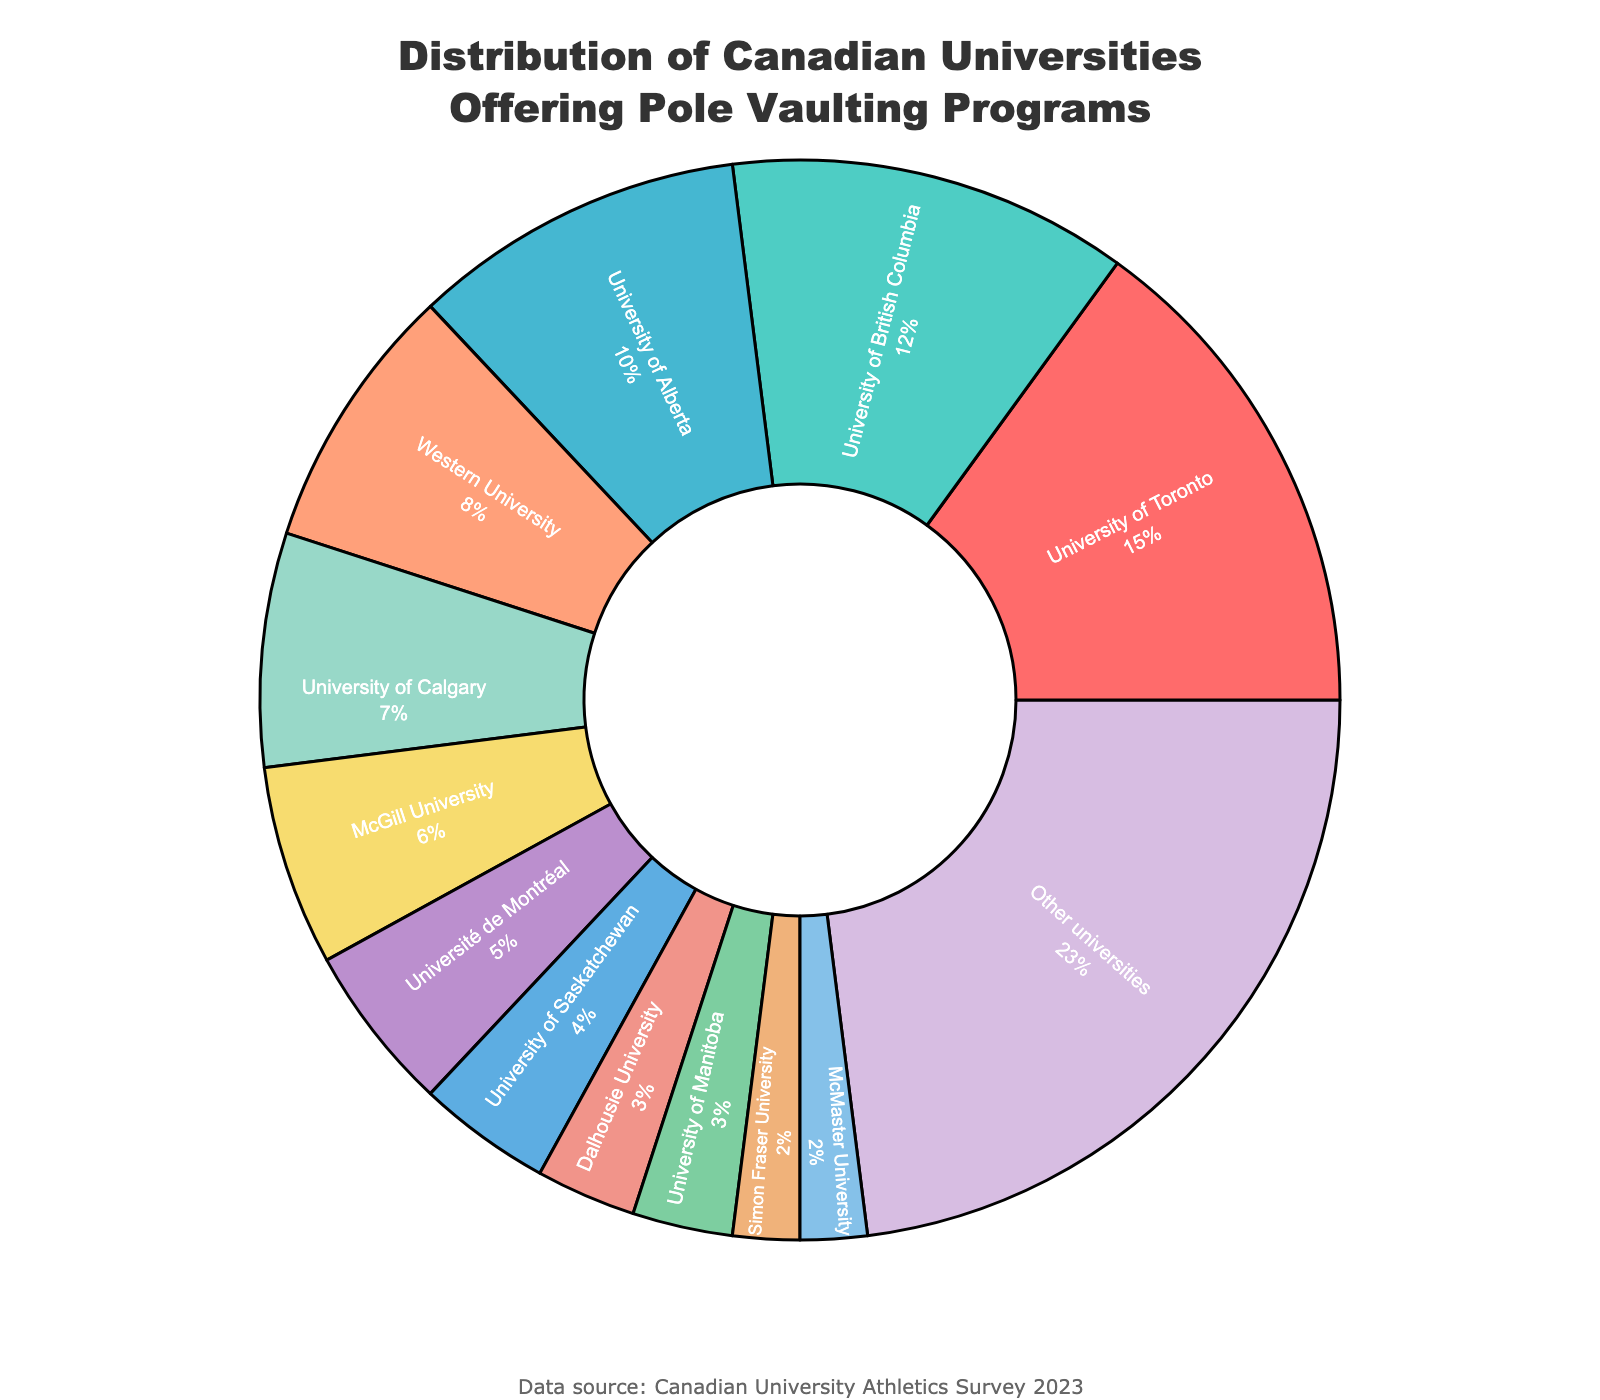Which university has the highest percentage of pole vaulting programs? Look at the slice of the pie chart with the largest area. The label indicates that the University of Toronto has the highest percentage of pole vaulting programs.
Answer: University of Toronto Which universities have the same percentage of pole vaulting programs offered? Observing the chart, the University of Manitoba and Dalhousie University both have equally-sized slices with the same percentage labels. They both offer 3% of the programs.
Answer: University of Manitoba and Dalhousie University What is the combined percentage of pole vaulting programs offered by the University of Saskatchewan and Simon Fraser University? Locate the slices labeled University of Saskatchewan (4%) and Simon Fraser University (2%) and add these percentages together: 4% + 2% = 6%.
Answer: 6% How does the percentage offered by Western University compare to McGill University? Find the slices for both universities. Western University's percentage (8%) is larger than McGill University's percentage (6%).
Answer: Western University > McGill University Which university among the top three has the lowest percentage of pole vaulting programs? Identify the top three universities based on slices: University of Toronto (15%), University of British Columbia (12%), and University of Alberta (10%). The University of Alberta, with 10%, is the lowest among these three.
Answer: University of Alberta What is the total percentage of pole vaulting programs offered by universities other than the ones listed individually? Refer to the 'Other universities' slice, which summarizes the programs offered by other universities not listed individually and has a percentage labeled as 23%.
Answer: 23% How much greater is the percentage offered by the University of Calgary compared to McMaster University? Identify the University of Calgary's percentage (7%) and McMaster University's percentage (2%) and subtract: 7% - 2% = 5%.
Answer: 5% Which university is represented by a red slice? Based on the description, the red slice denotes the University of Toronto. Review the color palette and match it with the described details.
Answer: University of Toronto 